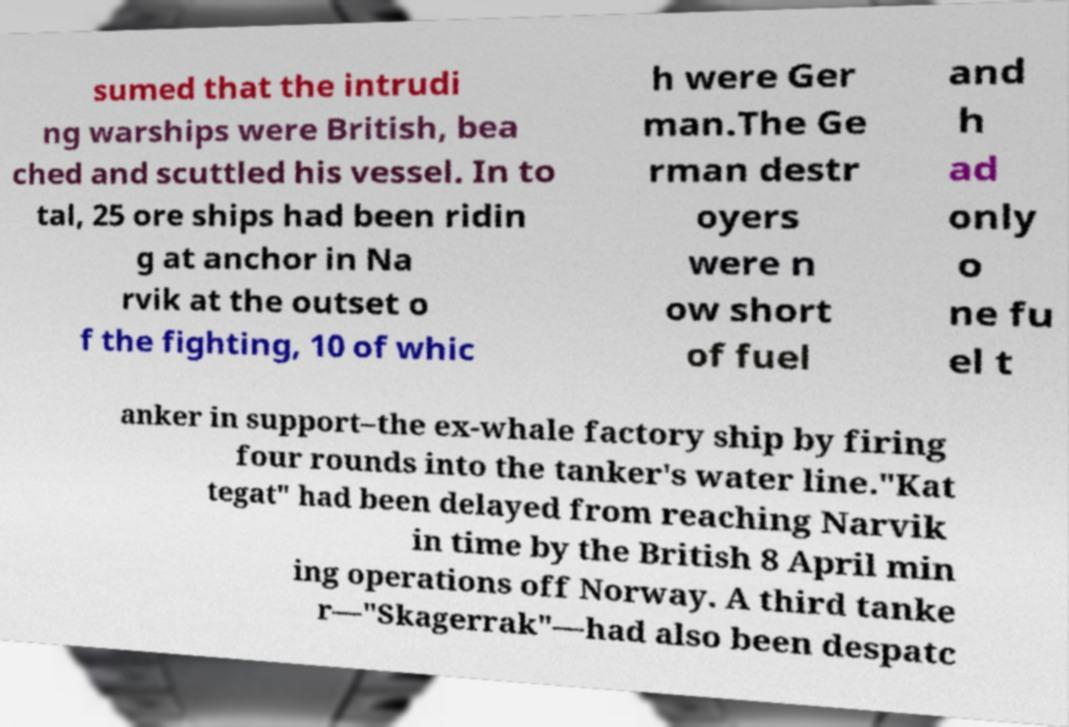Can you read and provide the text displayed in the image?This photo seems to have some interesting text. Can you extract and type it out for me? sumed that the intrudi ng warships were British, bea ched and scuttled his vessel. In to tal, 25 ore ships had been ridin g at anchor in Na rvik at the outset o f the fighting, 10 of whic h were Ger man.The Ge rman destr oyers were n ow short of fuel and h ad only o ne fu el t anker in support–the ex-whale factory ship by firing four rounds into the tanker's water line."Kat tegat" had been delayed from reaching Narvik in time by the British 8 April min ing operations off Norway. A third tanke r—"Skagerrak"—had also been despatc 